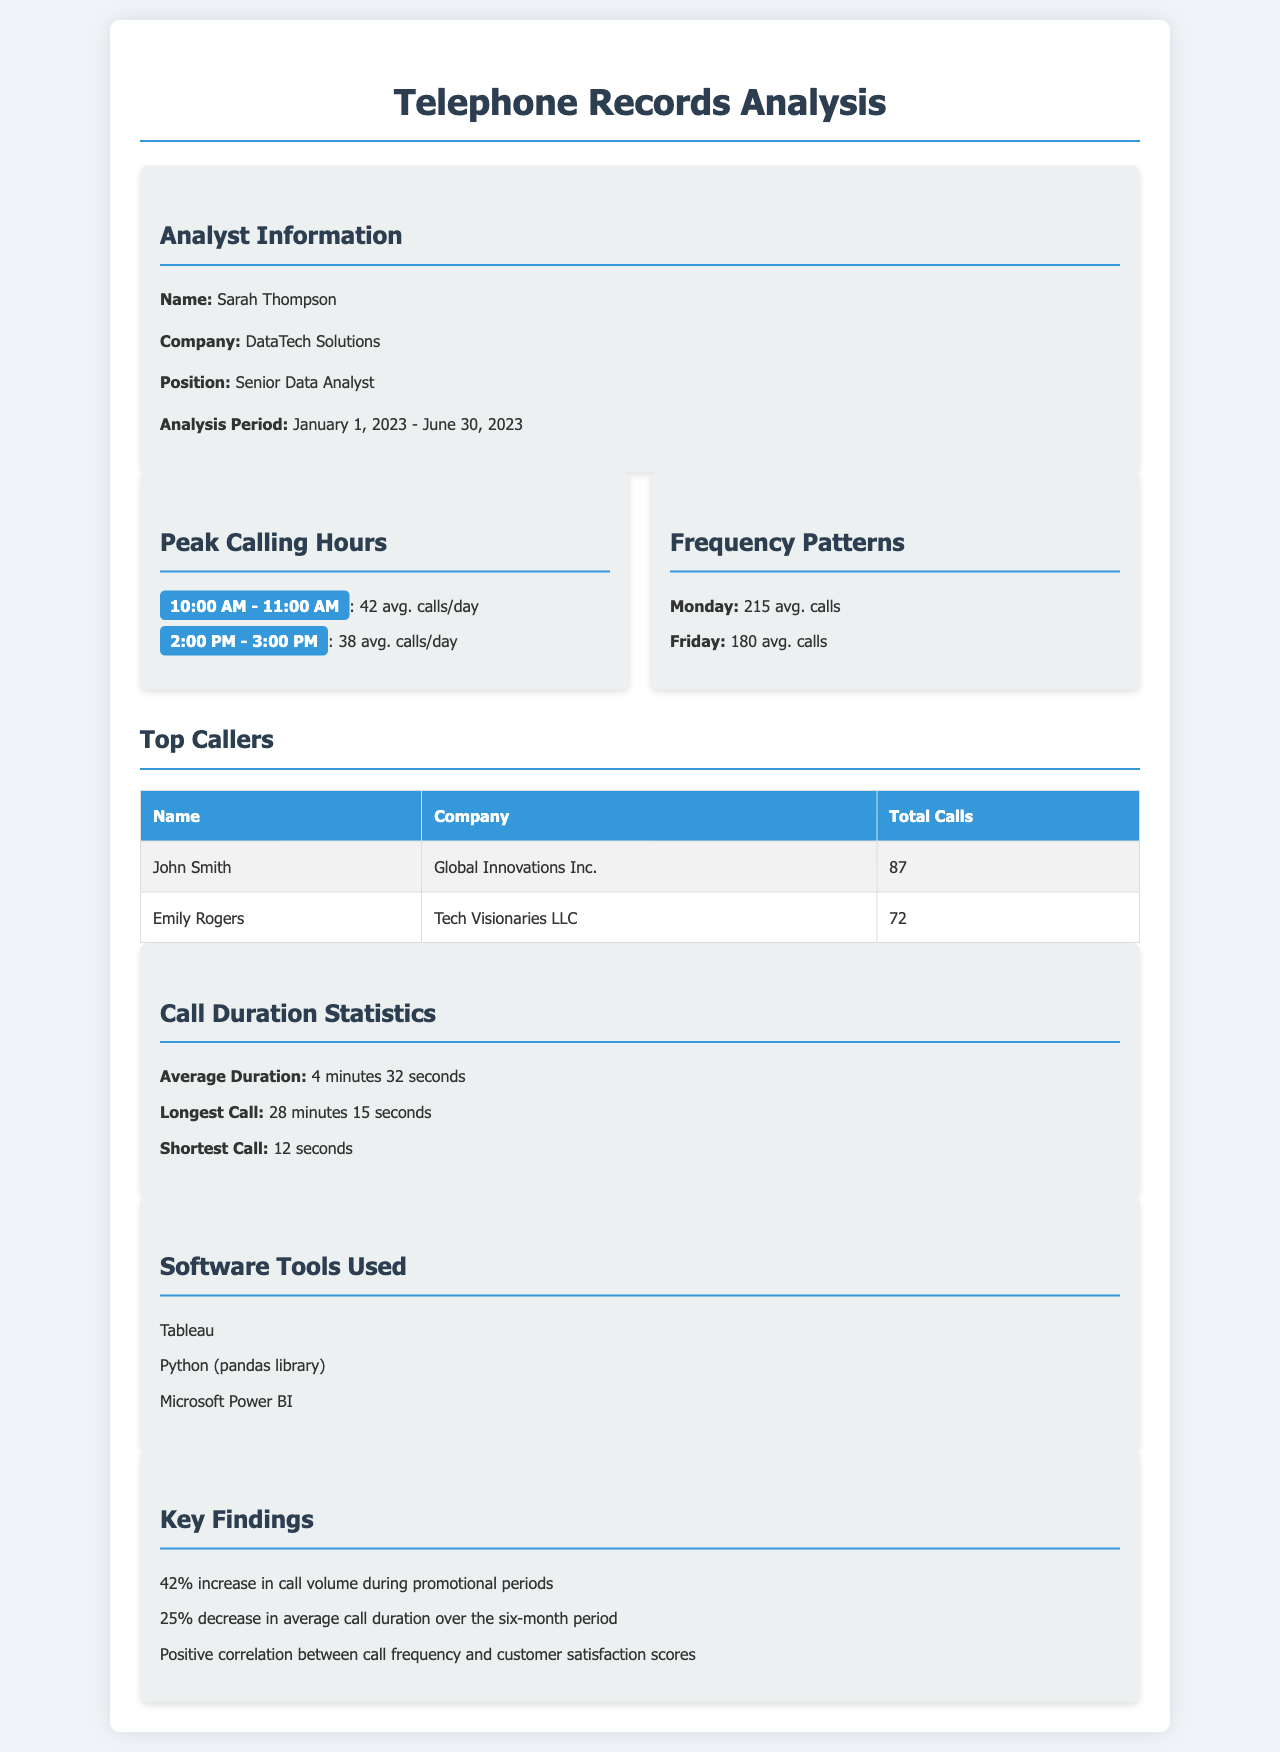What is the analysis period? The analysis period is specified in the document as the time frame under evaluation, which is January 1, 2023 - June 30, 2023.
Answer: January 1, 2023 - June 30, 2023 Who is the analyst? The analyst's name is provided in the document, highlighting the person responsible for the analysis.
Answer: Sarah Thompson What time frame has the peak calling hours? The document lists specific hours where calling activity is notably high, which is essential for understanding customer behavior.
Answer: 10:00 AM - 11:00 AM What was the average call duration? The average call duration is a crucial metric mentioned in the document that contributes to understanding call patterns.
Answer: 4 minutes 32 seconds Which day had the highest average calls? The document identifies specific days with the highest calling activity, useful for making data-driven decisions.
Answer: Monday How many calls did John Smith make? The document provides specific data on individual callers, enabling insights into caller behavior and patterns.
Answer: 87 What percentage increase in call volume occurred during promotional periods? The document highlights key findings, including changes in call volume due to promotions, providing insights into business outcomes.
Answer: 42% What software tools were used for the analysis? The document lists specific tools that facilitated the analysis, important for understanding the methodologies applied.
Answer: Tableau, Python (pandas library), Microsoft Power BI What is the longest call duration recorded? The longest call duration is a specific statistic in the document that reflects extreme case scenarios for customer interactions.
Answer: 28 minutes 15 seconds 